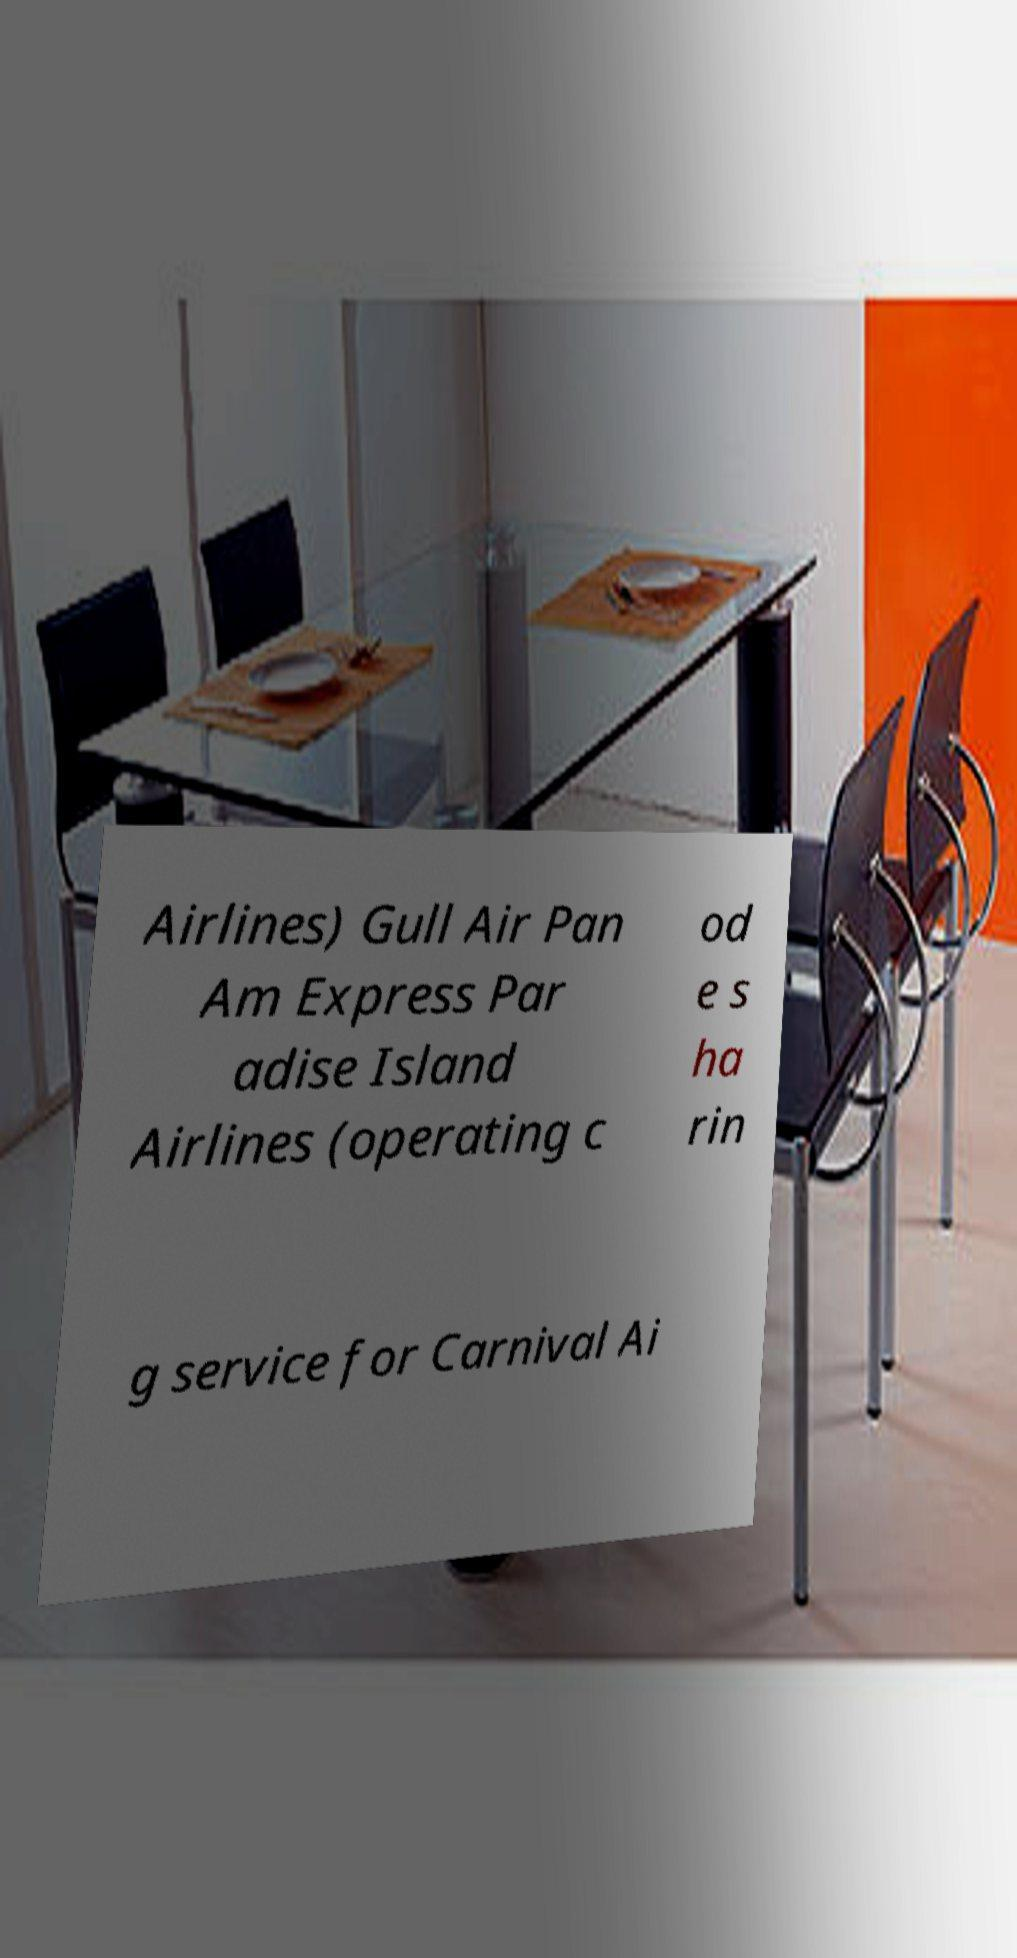What messages or text are displayed in this image? I need them in a readable, typed format. Airlines) Gull Air Pan Am Express Par adise Island Airlines (operating c od e s ha rin g service for Carnival Ai 